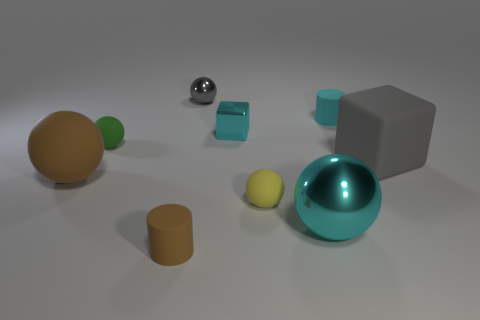Subtract all gray balls. How many balls are left? 4 Subtract all small green spheres. How many spheres are left? 4 Subtract 1 balls. How many balls are left? 4 Subtract all blue spheres. Subtract all red cylinders. How many spheres are left? 5 Subtract all cubes. How many objects are left? 7 Subtract 0 red cubes. How many objects are left? 9 Subtract all small brown things. Subtract all metal balls. How many objects are left? 6 Add 2 cyan matte cylinders. How many cyan matte cylinders are left? 3 Add 8 tiny gray balls. How many tiny gray balls exist? 9 